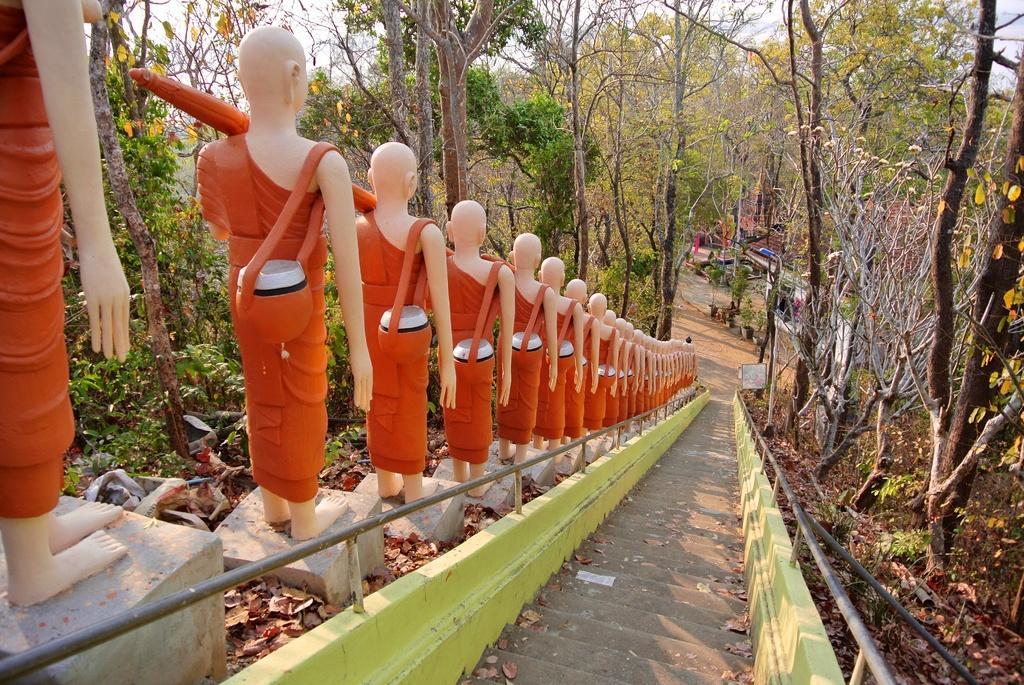In one or two sentences, can you explain what this image depicts? In the center of the image we can see statues and stairs. In the background we can see stairs, building, light and sky. 